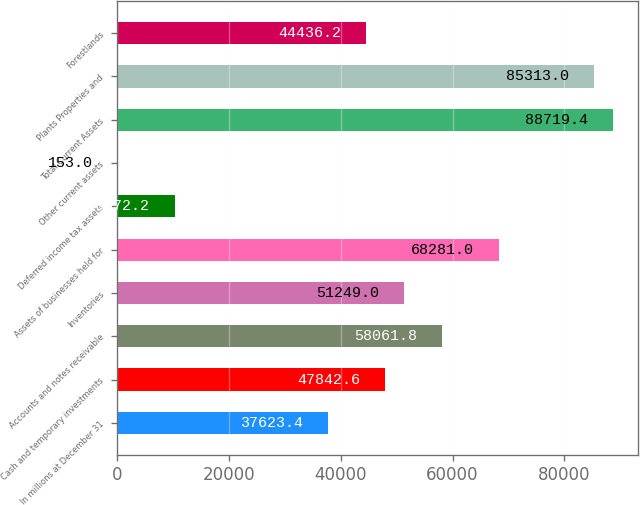Convert chart. <chart><loc_0><loc_0><loc_500><loc_500><bar_chart><fcel>In millions at December 31<fcel>Cash and temporary investments<fcel>Accounts and notes receivable<fcel>Inventories<fcel>Assets of businesses held for<fcel>Deferred income tax assets<fcel>Other current assets<fcel>Total Current Assets<fcel>Plants Properties and<fcel>Forestlands<nl><fcel>37623.4<fcel>47842.6<fcel>58061.8<fcel>51249<fcel>68281<fcel>10372.2<fcel>153<fcel>88719.4<fcel>85313<fcel>44436.2<nl></chart> 